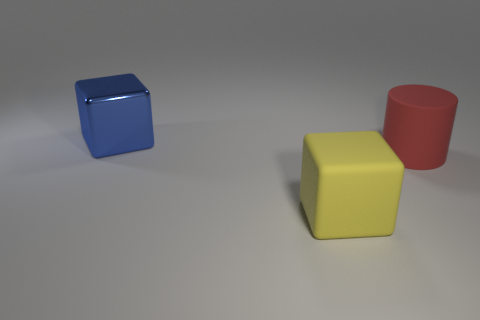How many other things are the same color as the big rubber cube?
Offer a very short reply. 0. The large matte thing that is in front of the matte object that is behind the big thing that is in front of the big rubber cylinder is what shape?
Give a very brief answer. Cube. How big is the thing behind the large red matte thing?
Keep it short and to the point. Large. What is the shape of the blue shiny object that is the same size as the red object?
Make the answer very short. Cube. What number of objects are large shiny cubes or rubber objects behind the yellow thing?
Keep it short and to the point. 2. There is a cube on the right side of the blue metallic cube that is behind the big yellow matte block; how many large blocks are behind it?
Ensure brevity in your answer.  1. What is the color of the block that is made of the same material as the red cylinder?
Your answer should be compact. Yellow. There is a cube that is in front of the blue block; does it have the same size as the large blue shiny block?
Keep it short and to the point. Yes. What number of things are either yellow matte things or red rubber objects?
Your answer should be compact. 2. There is a cube that is left of the cube right of the big block behind the yellow thing; what is it made of?
Provide a succinct answer. Metal. 